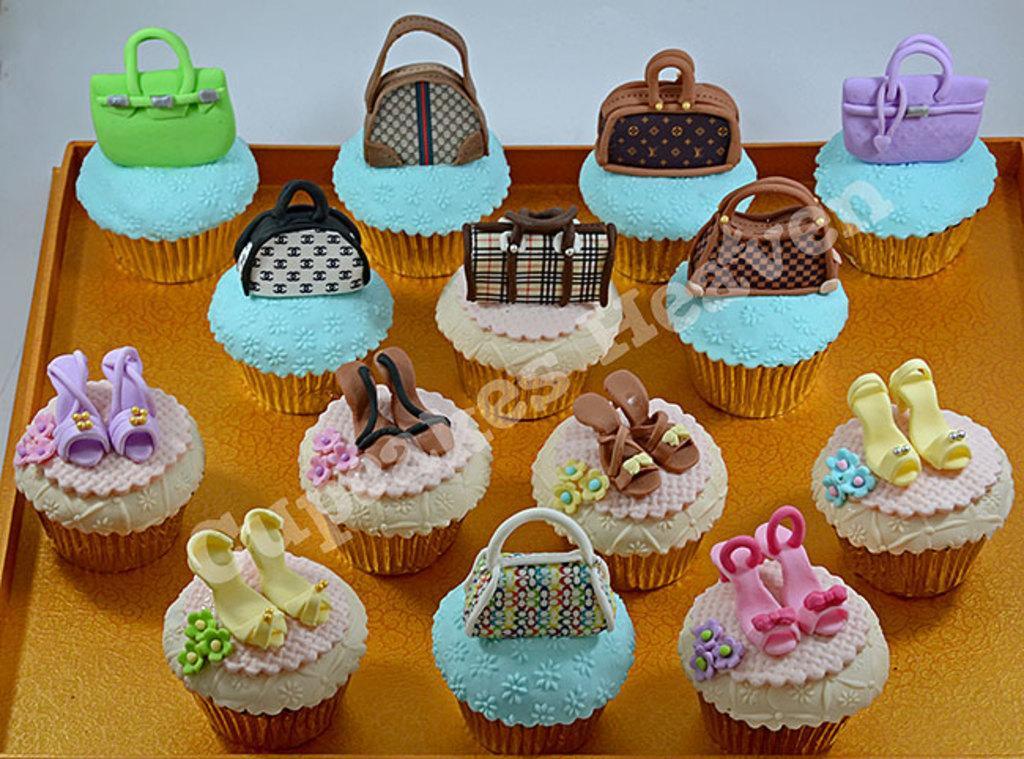In one or two sentences, can you explain what this image depicts? Here I can see a tray which consists of few cupcakes on it. 